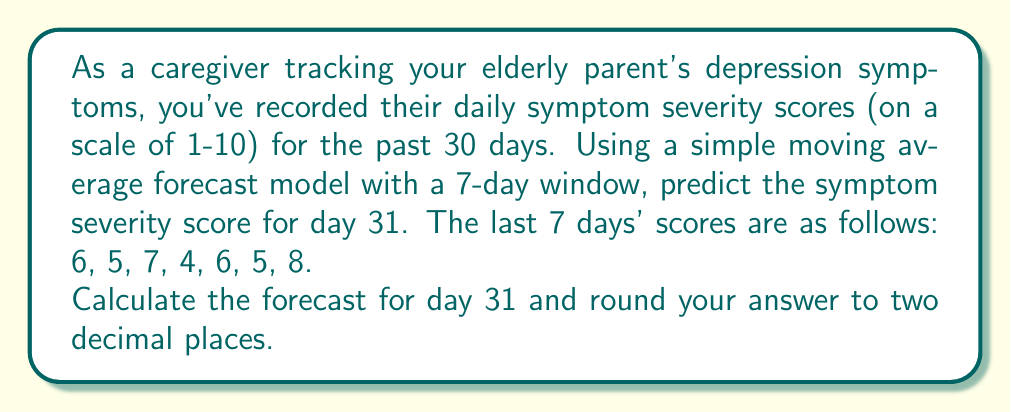Could you help me with this problem? To solve this problem, we'll use a simple moving average forecast model. This method is useful for short-term forecasting in time series analysis, particularly when dealing with data that doesn't show strong trends or seasonality.

The formula for a simple moving average is:

$$ SMA = \frac{\sum_{i=1}^{n} x_i}{n} $$

Where:
$SMA$ is the Simple Moving Average
$x_i$ are the individual values
$n$ is the number of periods (in this case, 7 days)

Given the last 7 days' scores: 6, 5, 7, 4, 6, 5, 8

Step 1: Sum the values
$$ \sum_{i=1}^{7} x_i = 6 + 5 + 7 + 4 + 6 + 5 + 8 = 41 $$

Step 2: Divide by the number of periods (7)
$$ SMA = \frac{41}{7} \approx 5.8571 $$

Step 3: Round to two decimal places
$$ 5.8571 \approx 5.86 $$

Therefore, the forecast for day 31, based on the simple moving average of the last 7 days, is 5.86.
Answer: 5.86 